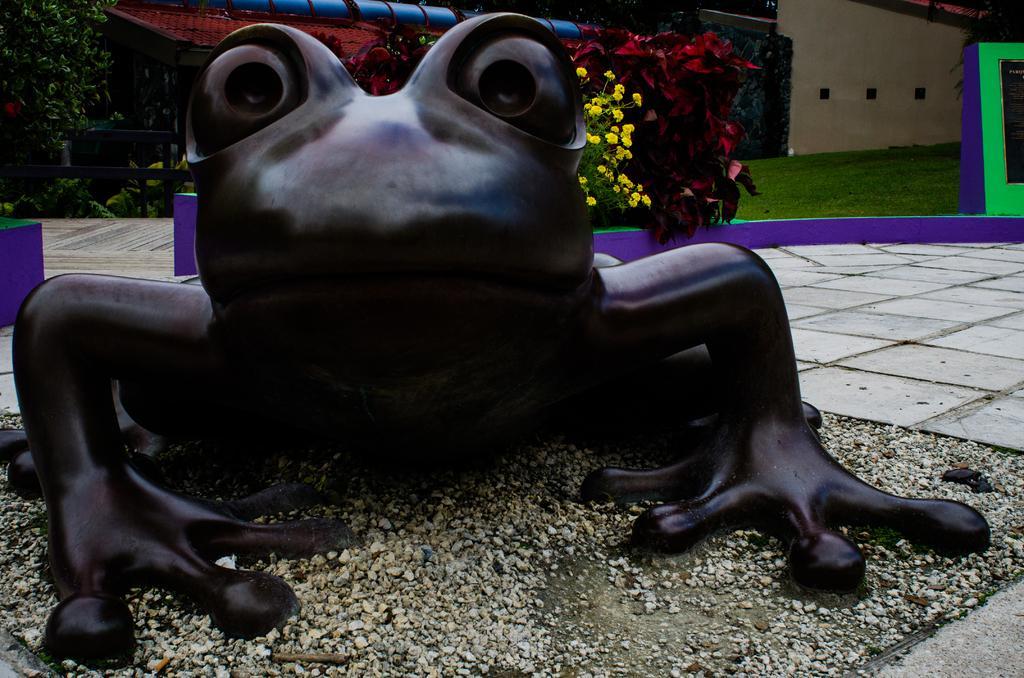Could you give a brief overview of what you see in this image? In this picture we can see the statue of a frog. Here we can see many small stone. In the back we can see plants, trees, flowers, building and shade. Here we can see grass near to the concrete board. 